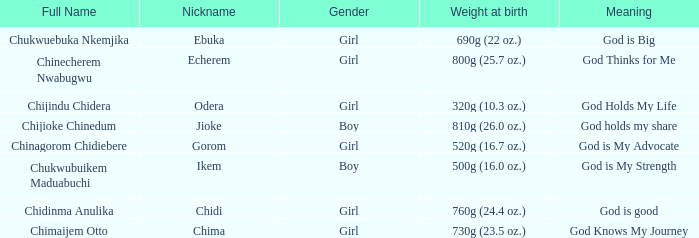How much did the baby who name means God knows my journey weigh at birth? 730g (23.5 oz.). 